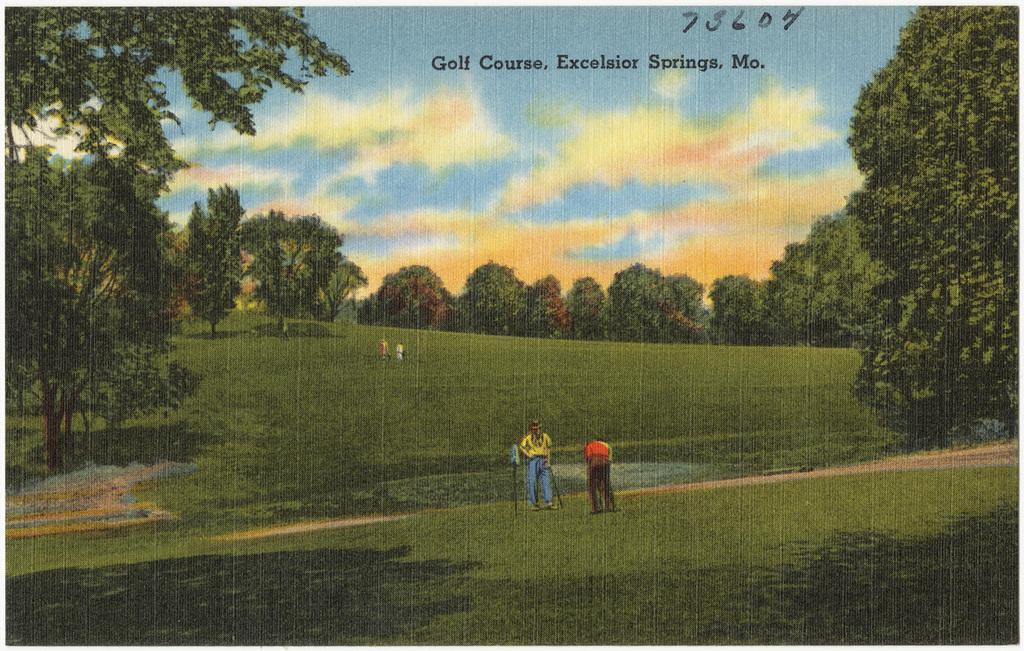What type of artwork is shown in the image? The image is a canvas drawing. What activity are the two men in the drawing engaged in? The drawing depicts two men playing golf. Where is the golf game taking place? The golf game is taking place on a grass lawn. What can be seen in the background of the drawing? There are trees visible in the background of the drawing. What is visible at the top of the drawing? The sky is visible at the top of the drawing. What type of flower is growing on the golf club in the image? There is no flower growing on a golf club in the image; it depicts two men playing golf on a grass lawn. What size is the suit worn by one of the golfers in the image? There is no suit visible in the image, as the two men are depicted wearing golf attire. 